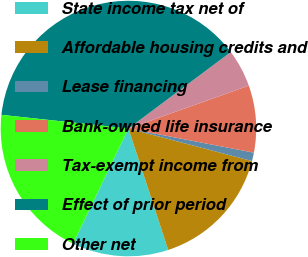<chart> <loc_0><loc_0><loc_500><loc_500><pie_chart><fcel>State income tax net of<fcel>Affordable housing credits and<fcel>Lease financing<fcel>Bank-owned life insurance<fcel>Tax-exempt income from<fcel>Effect of prior period<fcel>Other net<nl><fcel>12.17%<fcel>15.87%<fcel>1.07%<fcel>8.47%<fcel>4.77%<fcel>38.07%<fcel>19.57%<nl></chart> 